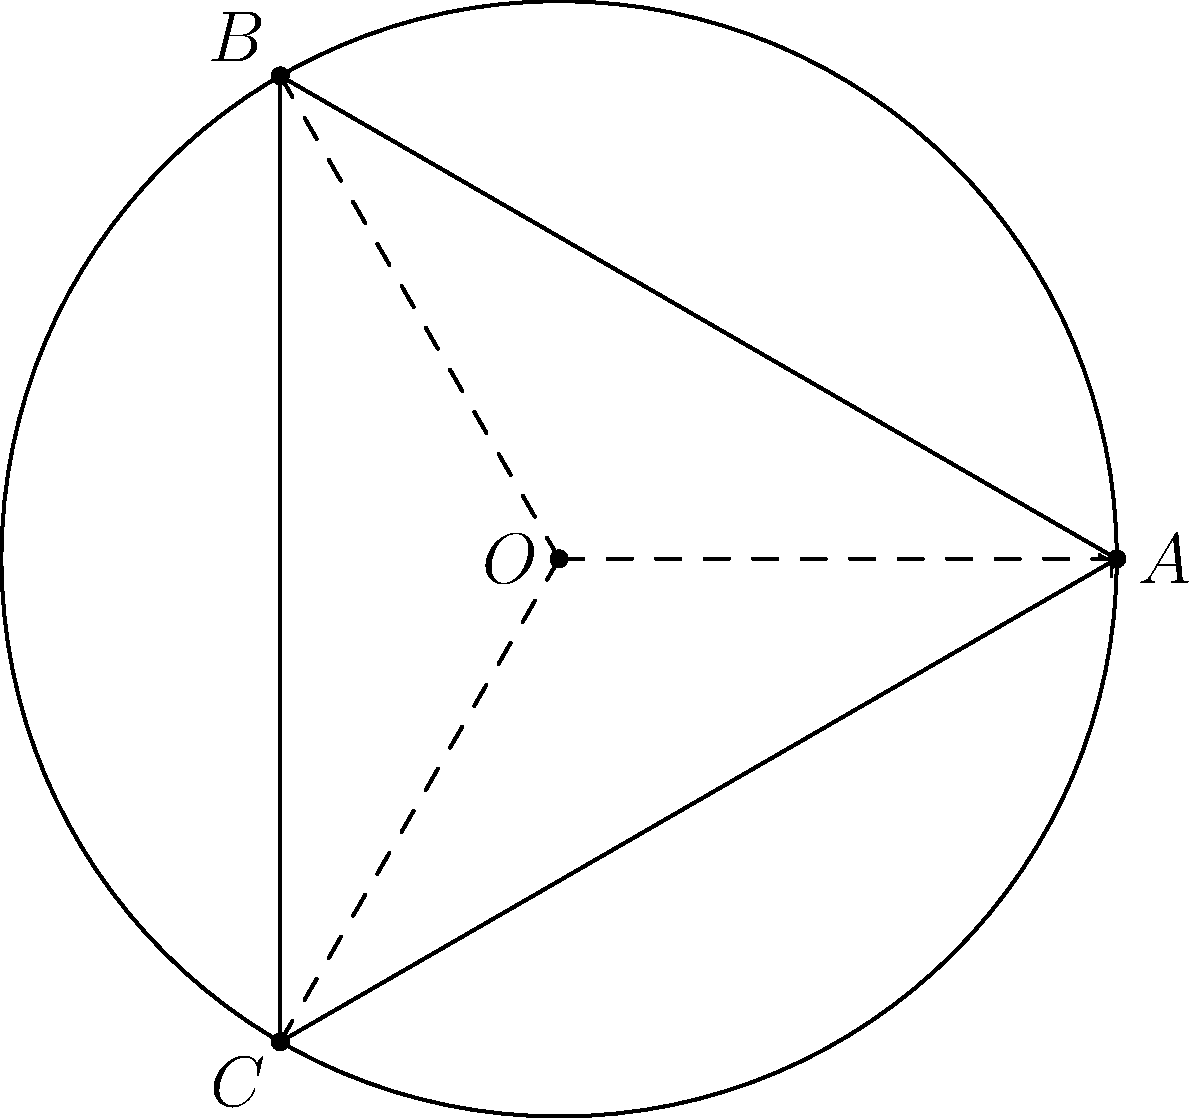In a circular particle accelerator, a proton moves from point $A$ to point $B$ to point $C$ as shown in the diagram. If the radius of the circular path is $R$ and the proton's speed is constant, what is the angle (in radians) through which the proton's velocity vector rotates during this motion? To solve this problem, we need to follow these steps:

1) First, observe that the path $A$ to $B$ to $C$ forms an equilateral triangle inscribed in the circle. This is because the central angles $\angle AOB$, $\angle BOC$, and $\angle COA$ are each $120^\circ$ or $\frac{2\pi}{3}$ radians.

2) The velocity vector of the proton is always tangent to the circular path and perpendicular to the radius at any point.

3) As the proton moves from $A$ to $B$, its velocity vector rotates by the same angle as the central angle $\angle AOB$, which is $\frac{2\pi}{3}$ radians.

4) Similarly, as it moves from $B$ to $C$, the velocity vector rotates by another $\frac{2\pi}{3}$ radians.

5) Therefore, the total rotation of the velocity vector from $A$ to $C$ is:

   $$\frac{2\pi}{3} + \frac{2\pi}{3} = \frac{4\pi}{3}$$ radians

This result is independent of the radius $R$ and the proton's speed, as long as the speed remains constant.
Answer: $\frac{4\pi}{3}$ radians 